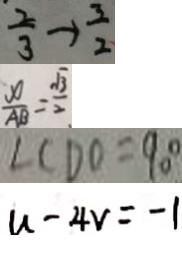Convert formula to latex. <formula><loc_0><loc_0><loc_500><loc_500>\frac { 2 } { 3 } \rightarrow \frac { 3 } { 2 } 
 \frac { x } { A B } = \frac { \sqrt { 3 } } { 2 } 
 \angle C D O = 9 0 ^ { \circ } 
 u - 4 v = - 1</formula> 